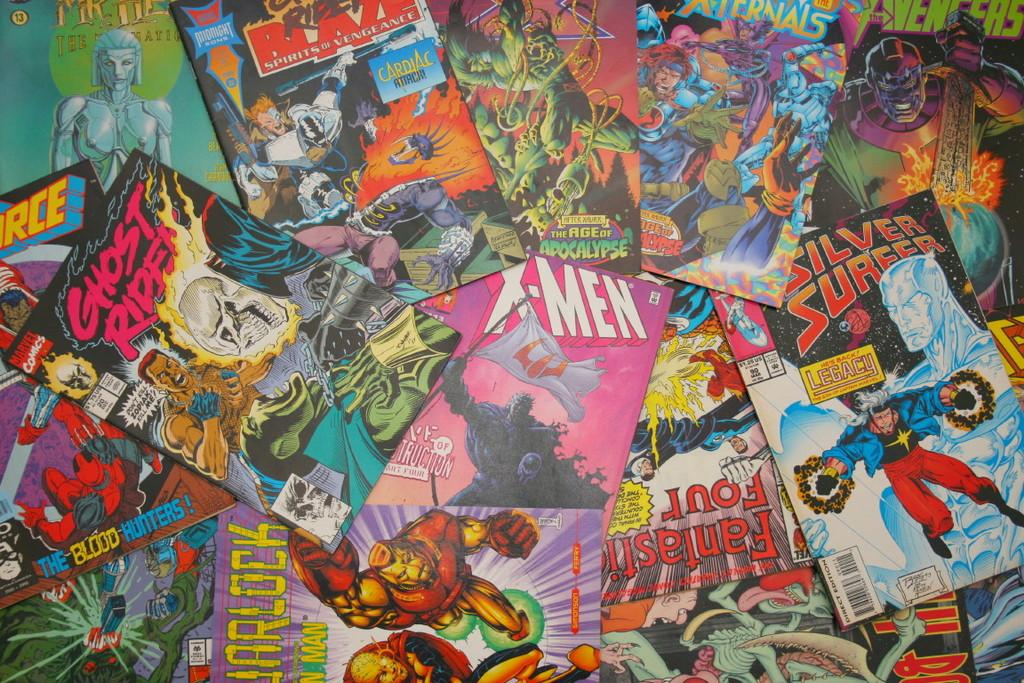<image>
Share a concise interpretation of the image provided. the name X Men is on the front of the comic 